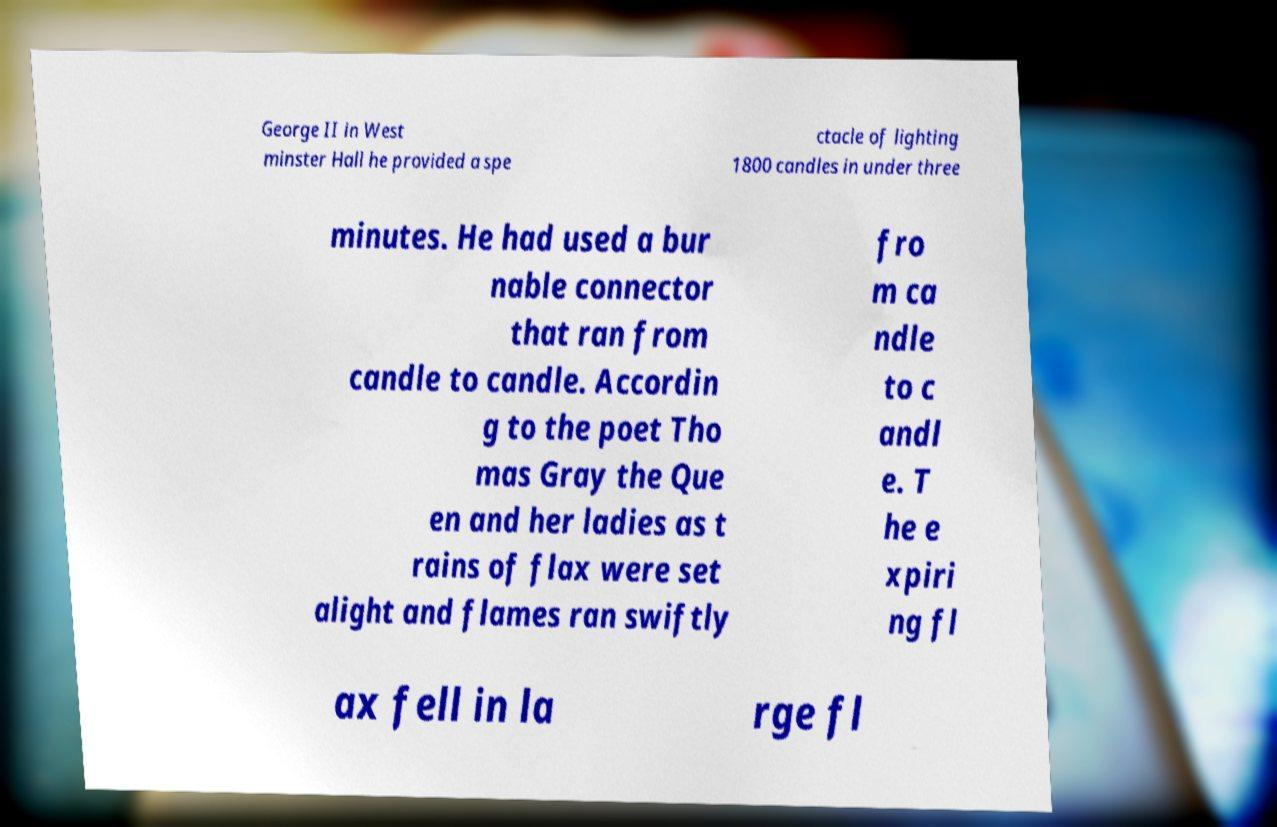I need the written content from this picture converted into text. Can you do that? George II in West minster Hall he provided a spe ctacle of lighting 1800 candles in under three minutes. He had used a bur nable connector that ran from candle to candle. Accordin g to the poet Tho mas Gray the Que en and her ladies as t rains of flax were set alight and flames ran swiftly fro m ca ndle to c andl e. T he e xpiri ng fl ax fell in la rge fl 